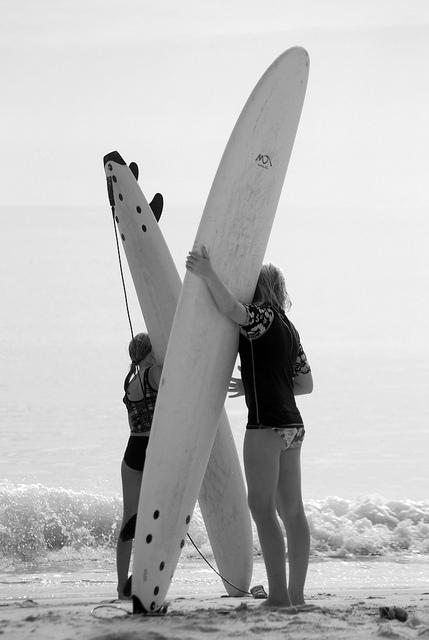Are they in the ocean?
Write a very short answer. Yes. What are these people holding?
Answer briefly. Surfboards. What is the gender of the two people?
Answer briefly. Female. 